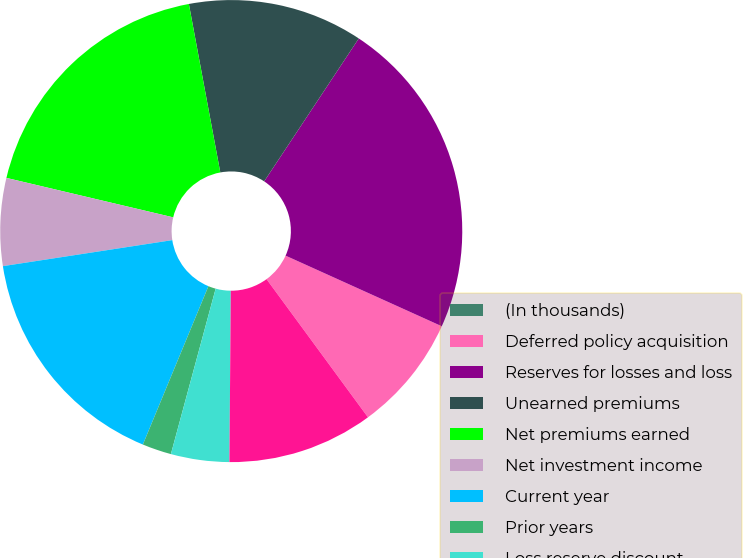<chart> <loc_0><loc_0><loc_500><loc_500><pie_chart><fcel>(In thousands)<fcel>Deferred policy acquisition<fcel>Reserves for losses and loss<fcel>Unearned premiums<fcel>Net premiums earned<fcel>Net investment income<fcel>Current year<fcel>Prior years<fcel>Loss reserve discount<fcel>Amortization of deferred<nl><fcel>0.0%<fcel>8.16%<fcel>22.44%<fcel>12.24%<fcel>18.36%<fcel>6.12%<fcel>16.32%<fcel>2.04%<fcel>4.08%<fcel>10.2%<nl></chart> 